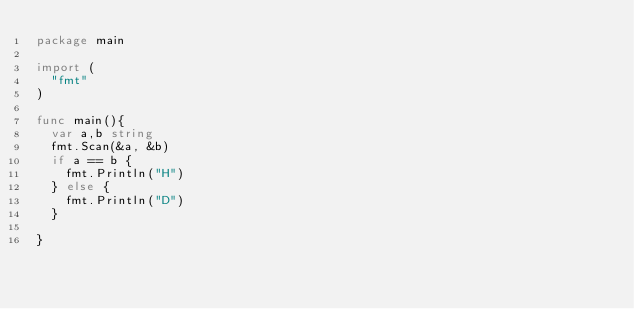<code> <loc_0><loc_0><loc_500><loc_500><_Go_>package main

import (
  "fmt"
)

func main(){
  var a,b string
  fmt.Scan(&a, &b)
  if a == b {
    fmt.Println("H")
  } else {
    fmt.Println("D")
  }
  
}</code> 